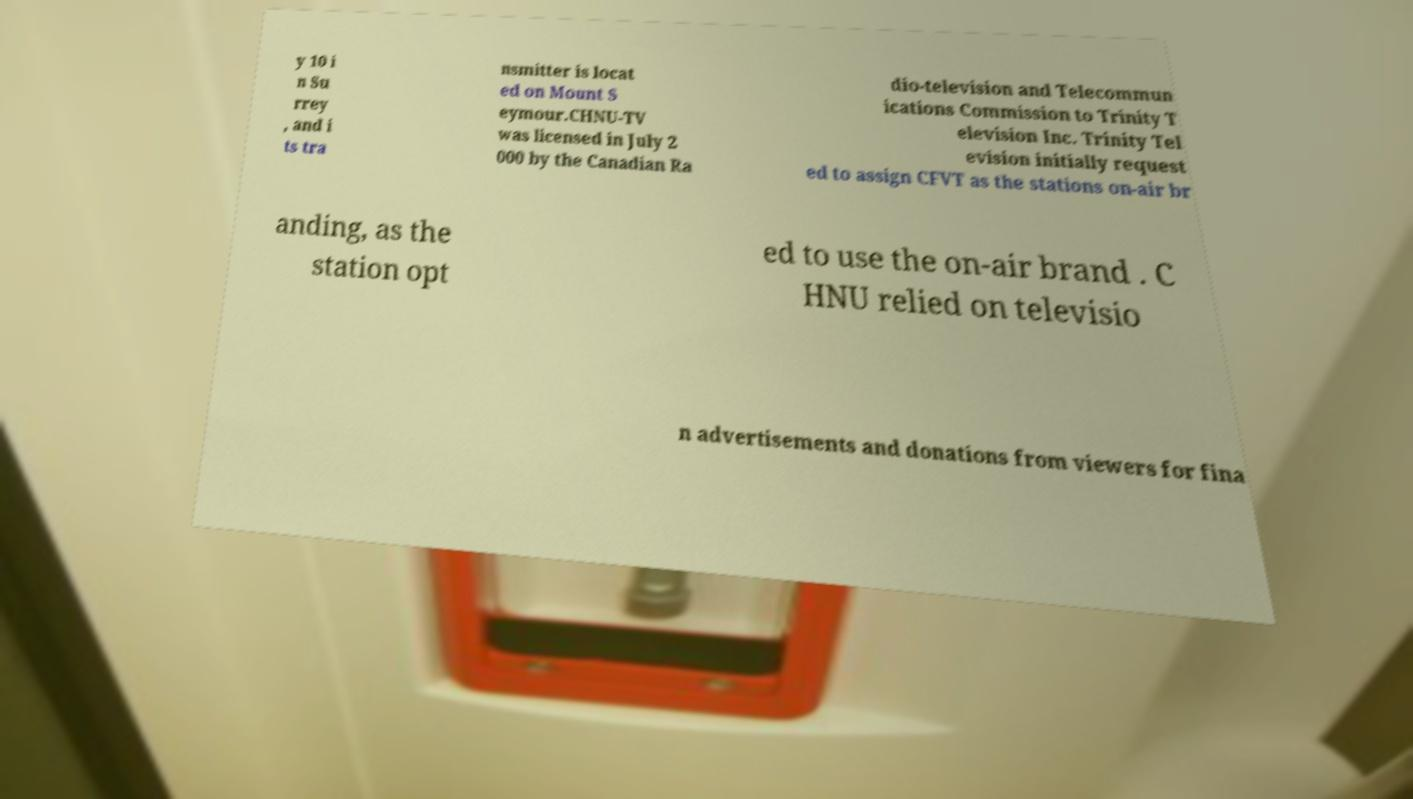There's text embedded in this image that I need extracted. Can you transcribe it verbatim? y 10 i n Su rrey , and i ts tra nsmitter is locat ed on Mount S eymour.CHNU-TV was licensed in July 2 000 by the Canadian Ra dio-television and Telecommun ications Commission to Trinity T elevision Inc. Trinity Tel evision initially request ed to assign CFVT as the stations on-air br anding, as the station opt ed to use the on-air brand . C HNU relied on televisio n advertisements and donations from viewers for fina 